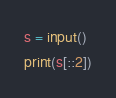Convert code to text. <code><loc_0><loc_0><loc_500><loc_500><_Python_>s = input()
print(s[::2])</code> 